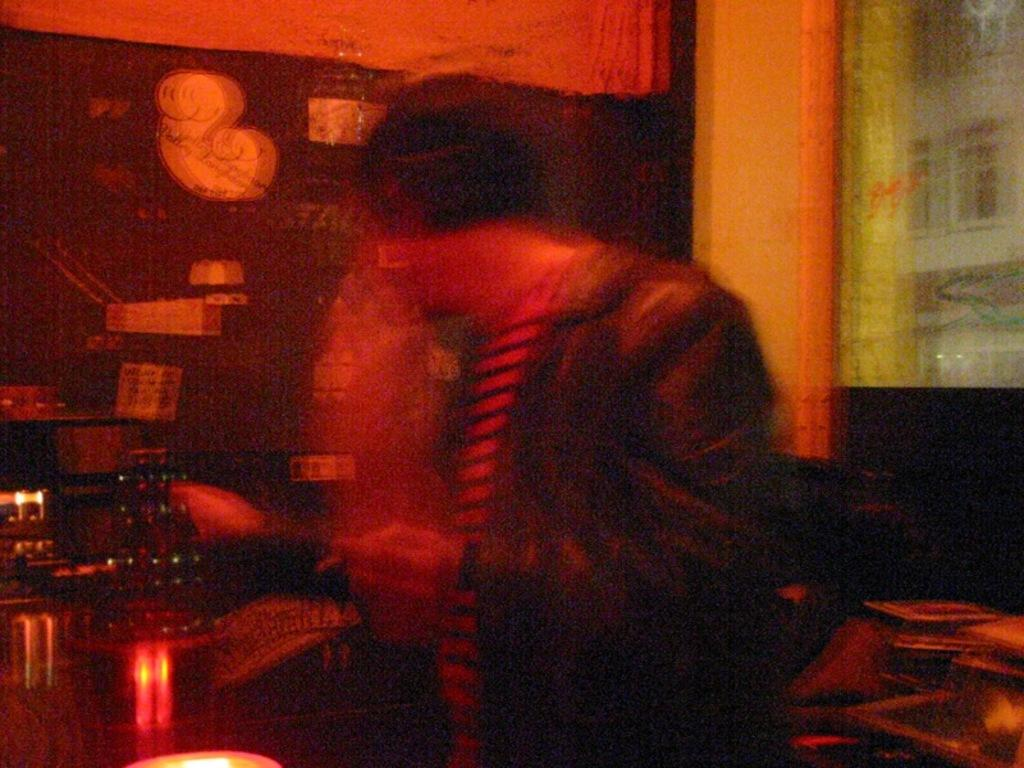Who or what is the main subject in the image? There is a person in the image. What can be seen around the person? There are objects around the person. What is on the left side of the image? There is a wall with objects on the left side of the image. Can you describe any architectural features in the image? Yes, there is a pillar in the image. How many lizards are crawling on the person in the image? There are no lizards present in the image. What type of house is depicted in the image? The image does not show a house; it only features a person, objects, a wall, and a pillar. 